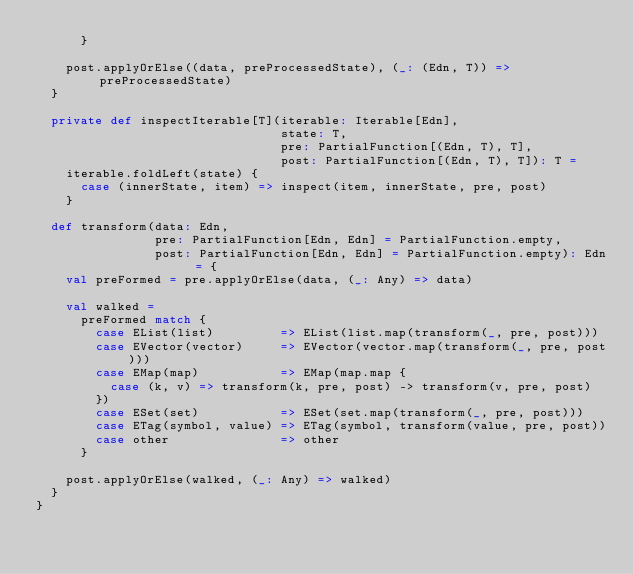Convert code to text. <code><loc_0><loc_0><loc_500><loc_500><_Scala_>      }

    post.applyOrElse((data, preProcessedState), (_: (Edn, T)) => preProcessedState)
  }

  private def inspectIterable[T](iterable: Iterable[Edn],
                                 state: T,
                                 pre: PartialFunction[(Edn, T), T],
                                 post: PartialFunction[(Edn, T), T]): T =
    iterable.foldLeft(state) {
      case (innerState, item) => inspect(item, innerState, pre, post)
    }

  def transform(data: Edn,
                pre: PartialFunction[Edn, Edn] = PartialFunction.empty,
                post: PartialFunction[Edn, Edn] = PartialFunction.empty): Edn = {
    val preFormed = pre.applyOrElse(data, (_: Any) => data)

    val walked =
      preFormed match {
        case EList(list)         => EList(list.map(transform(_, pre, post)))
        case EVector(vector)     => EVector(vector.map(transform(_, pre, post)))
        case EMap(map)           => EMap(map.map {
          case (k, v) => transform(k, pre, post) -> transform(v, pre, post)
        })
        case ESet(set)           => ESet(set.map(transform(_, pre, post)))
        case ETag(symbol, value) => ETag(symbol, transform(value, pre, post))
        case other               => other
      }

    post.applyOrElse(walked, (_: Any) => walked)
  }
}
</code> 